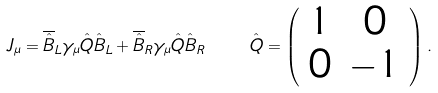Convert formula to latex. <formula><loc_0><loc_0><loc_500><loc_500>J _ { \mu } = \overline { \hat { B } } _ { L } \gamma _ { \mu } \hat { Q } \hat { B } _ { L } + \overline { \hat { B } } _ { R } \gamma _ { \mu } \hat { Q } \hat { B } _ { R } \quad \hat { Q } = \left ( \begin{array} { c c } 1 & 0 \\ 0 & - 1 \end{array} \right ) .</formula> 